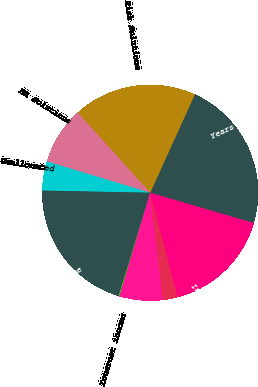Convert chart. <chart><loc_0><loc_0><loc_500><loc_500><pie_chart><fcel>Years ended December 31<fcel>Risk Solutions<fcel>HR Solutions<fcel>Unallocated<fcel>Operating income<fcel>Interest income<fcel>Interest expense<fcel>Other income<fcel>Income before income taxes<nl><fcel>22.75%<fcel>18.49%<fcel>8.62%<fcel>4.36%<fcel>20.62%<fcel>0.1%<fcel>6.49%<fcel>2.23%<fcel>16.36%<nl></chart> 